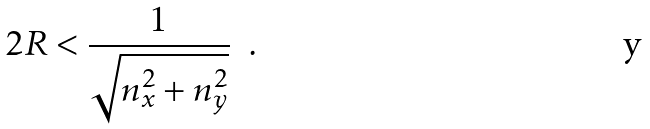Convert formula to latex. <formula><loc_0><loc_0><loc_500><loc_500>2 R < \frac { 1 } { \sqrt { n _ { x } ^ { 2 } + n _ { y } ^ { 2 } } } \ \ .</formula> 